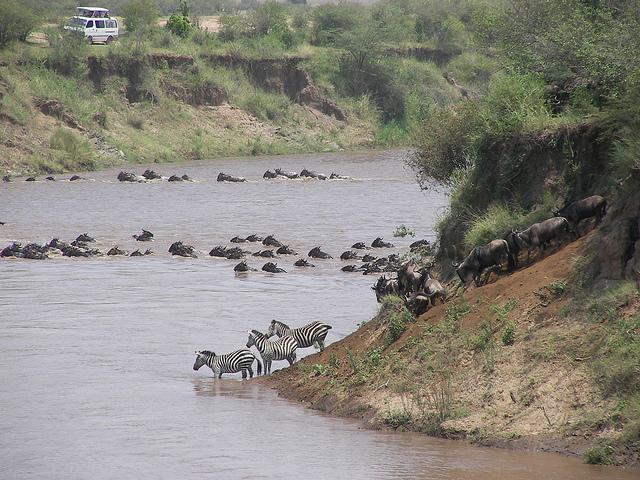What type of animals are entering the water?
Write a very short answer. Zebras. How many vehicles do you see?
Be succinct. 1. What color is the grass?
Give a very brief answer. Green. Are the oxen drowning?
Give a very brief answer. No. What kind of geographic feature is in the distance?
Keep it brief. Savannah. 